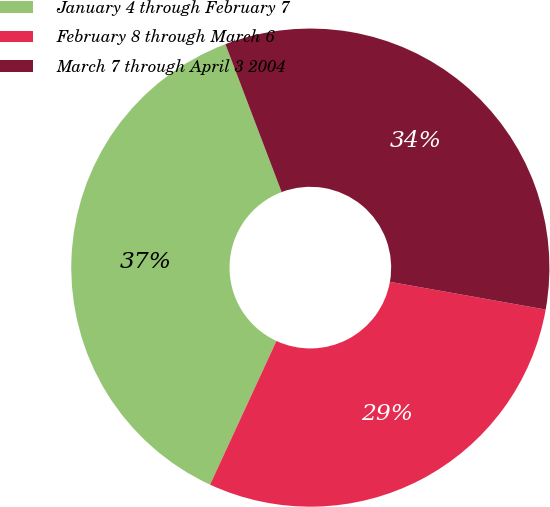Convert chart. <chart><loc_0><loc_0><loc_500><loc_500><pie_chart><fcel>January 4 through February 7<fcel>February 8 through March 6<fcel>March 7 through April 3 2004<nl><fcel>37.33%<fcel>29.08%<fcel>33.59%<nl></chart> 